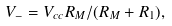Convert formula to latex. <formula><loc_0><loc_0><loc_500><loc_500>V _ { - } = V _ { c c } R _ { M } / ( R _ { M } + R _ { 1 } ) ,</formula> 